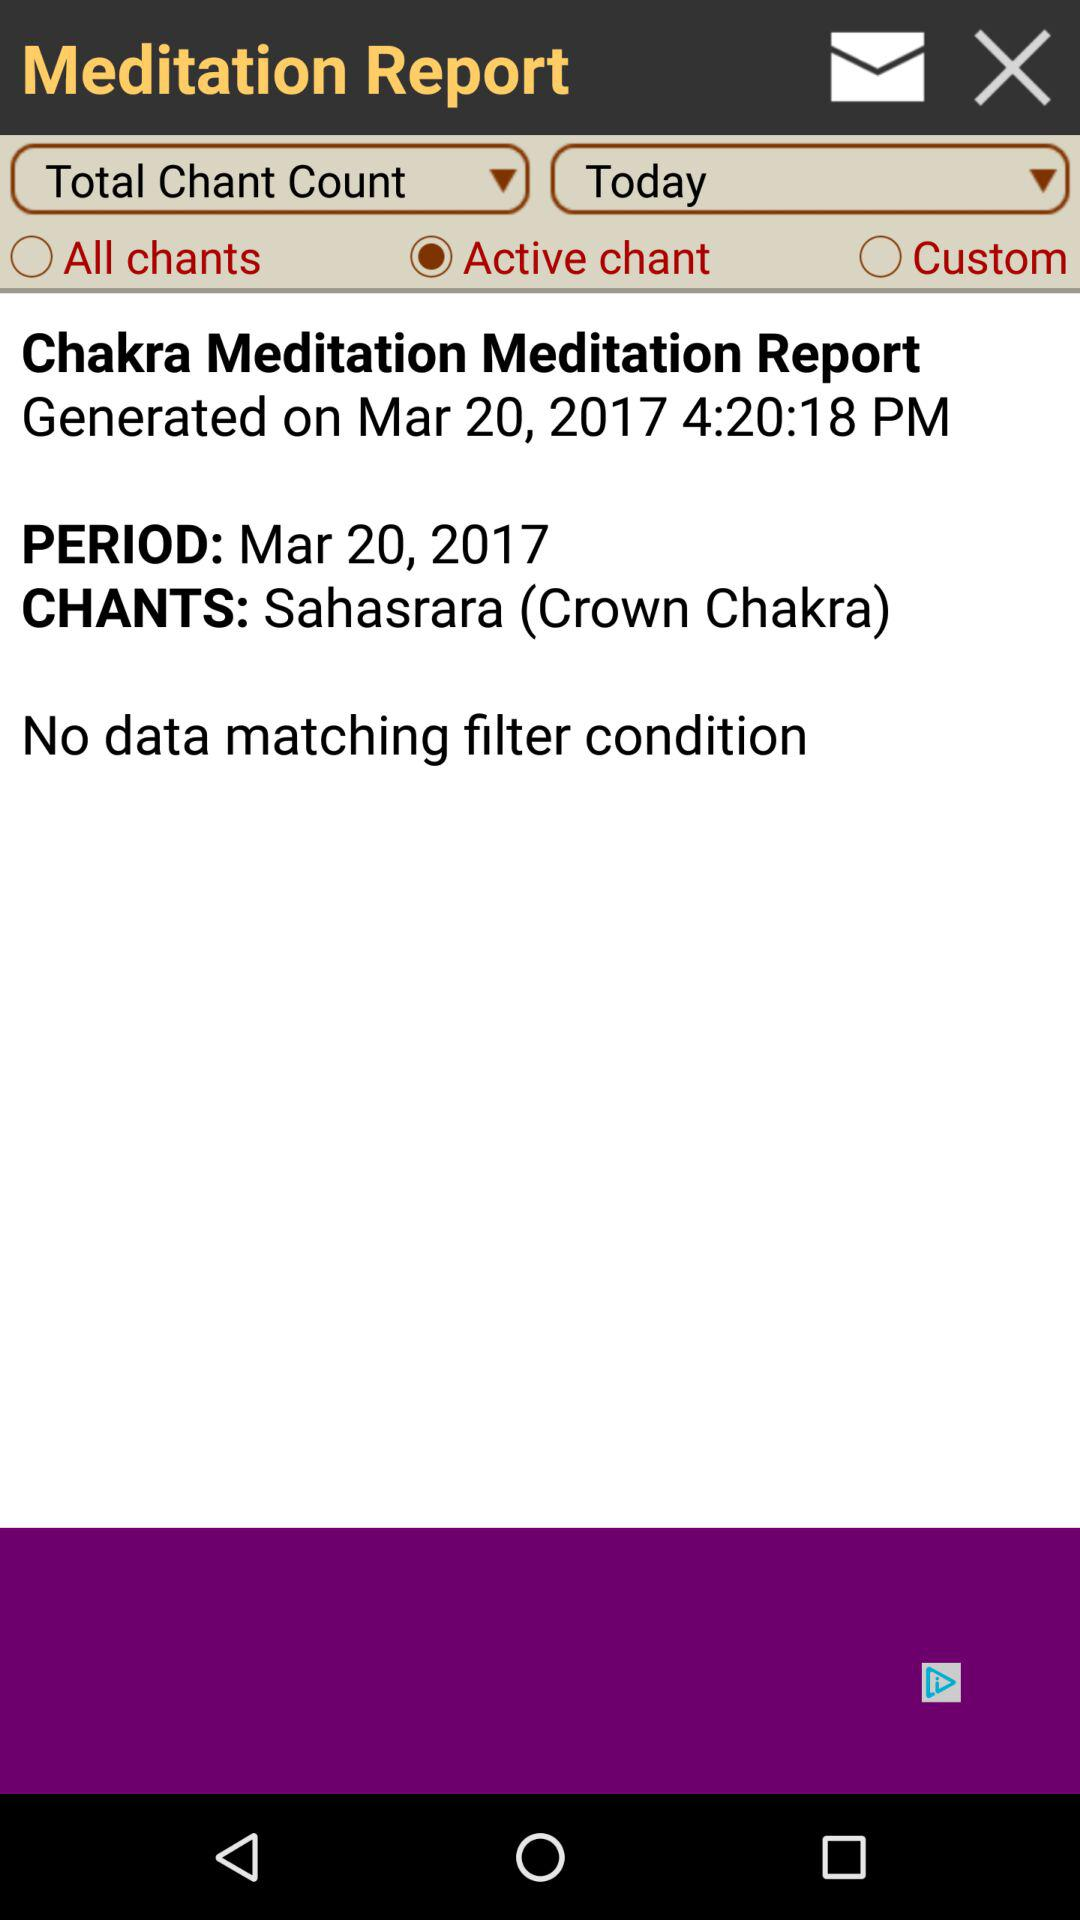Which option is selected? The selected option is "Active chant". 